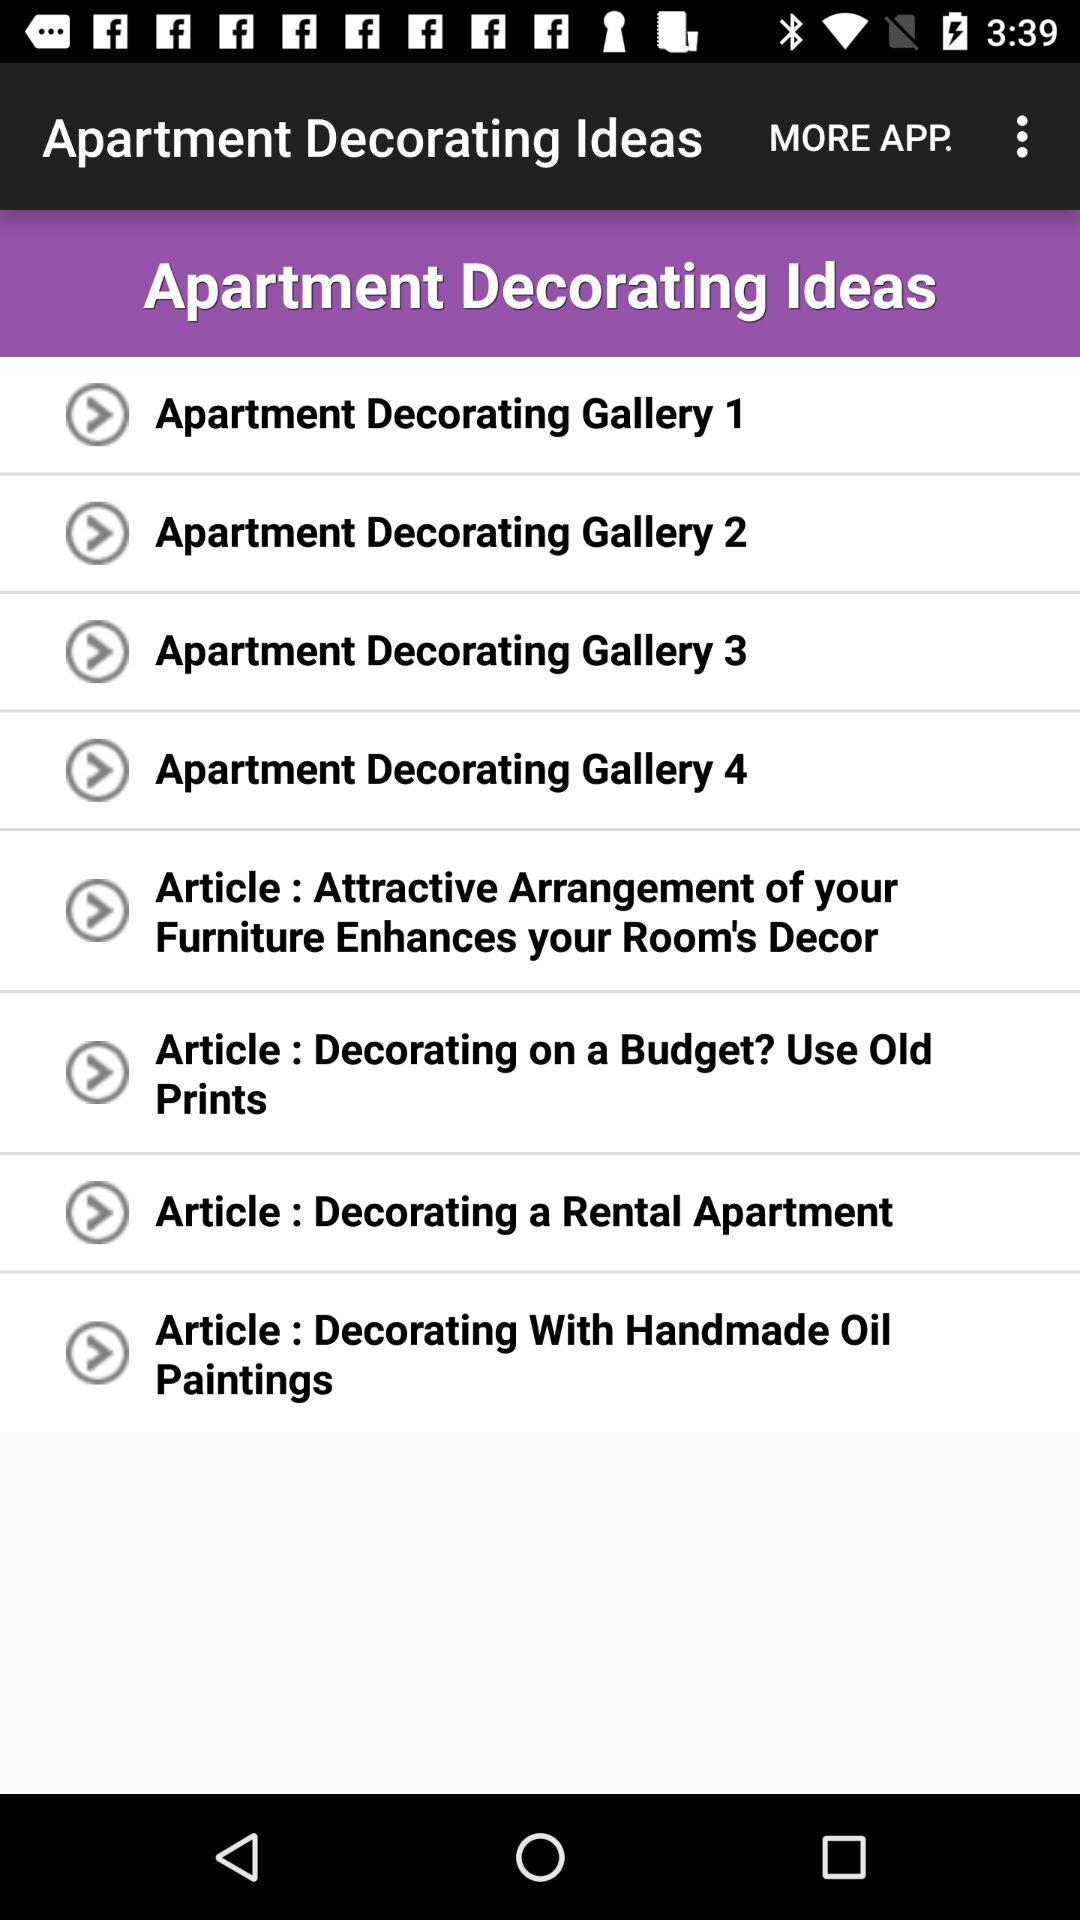How many apartment decorating galleries are there on this screen?
Answer the question using a single word or phrase. 4 